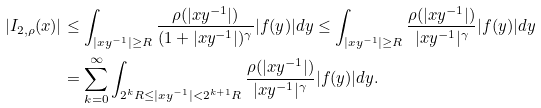<formula> <loc_0><loc_0><loc_500><loc_500>| I _ { 2 , \rho } ( x ) | & \leq \int _ { | x y ^ { - 1 } | \geq R } \frac { \rho ( | x y ^ { - 1 } | ) } { ( 1 + | x y ^ { - 1 } | ) ^ { \gamma } } | f ( y ) | d y \leq \int _ { | x y ^ { - 1 } | \geq R } \frac { \rho ( | x y ^ { - 1 } | ) } { | x y ^ { - 1 } | ^ { \gamma } } | f ( y ) | d y \\ & = \sum _ { k = 0 } ^ { \infty } \int _ { 2 ^ { k } R \leq | x y ^ { - 1 } | < 2 ^ { k + 1 } R } \frac { \rho ( | x y ^ { - 1 } | ) } { | x y ^ { - 1 } | ^ { \gamma } } | f ( y ) | d y .</formula> 